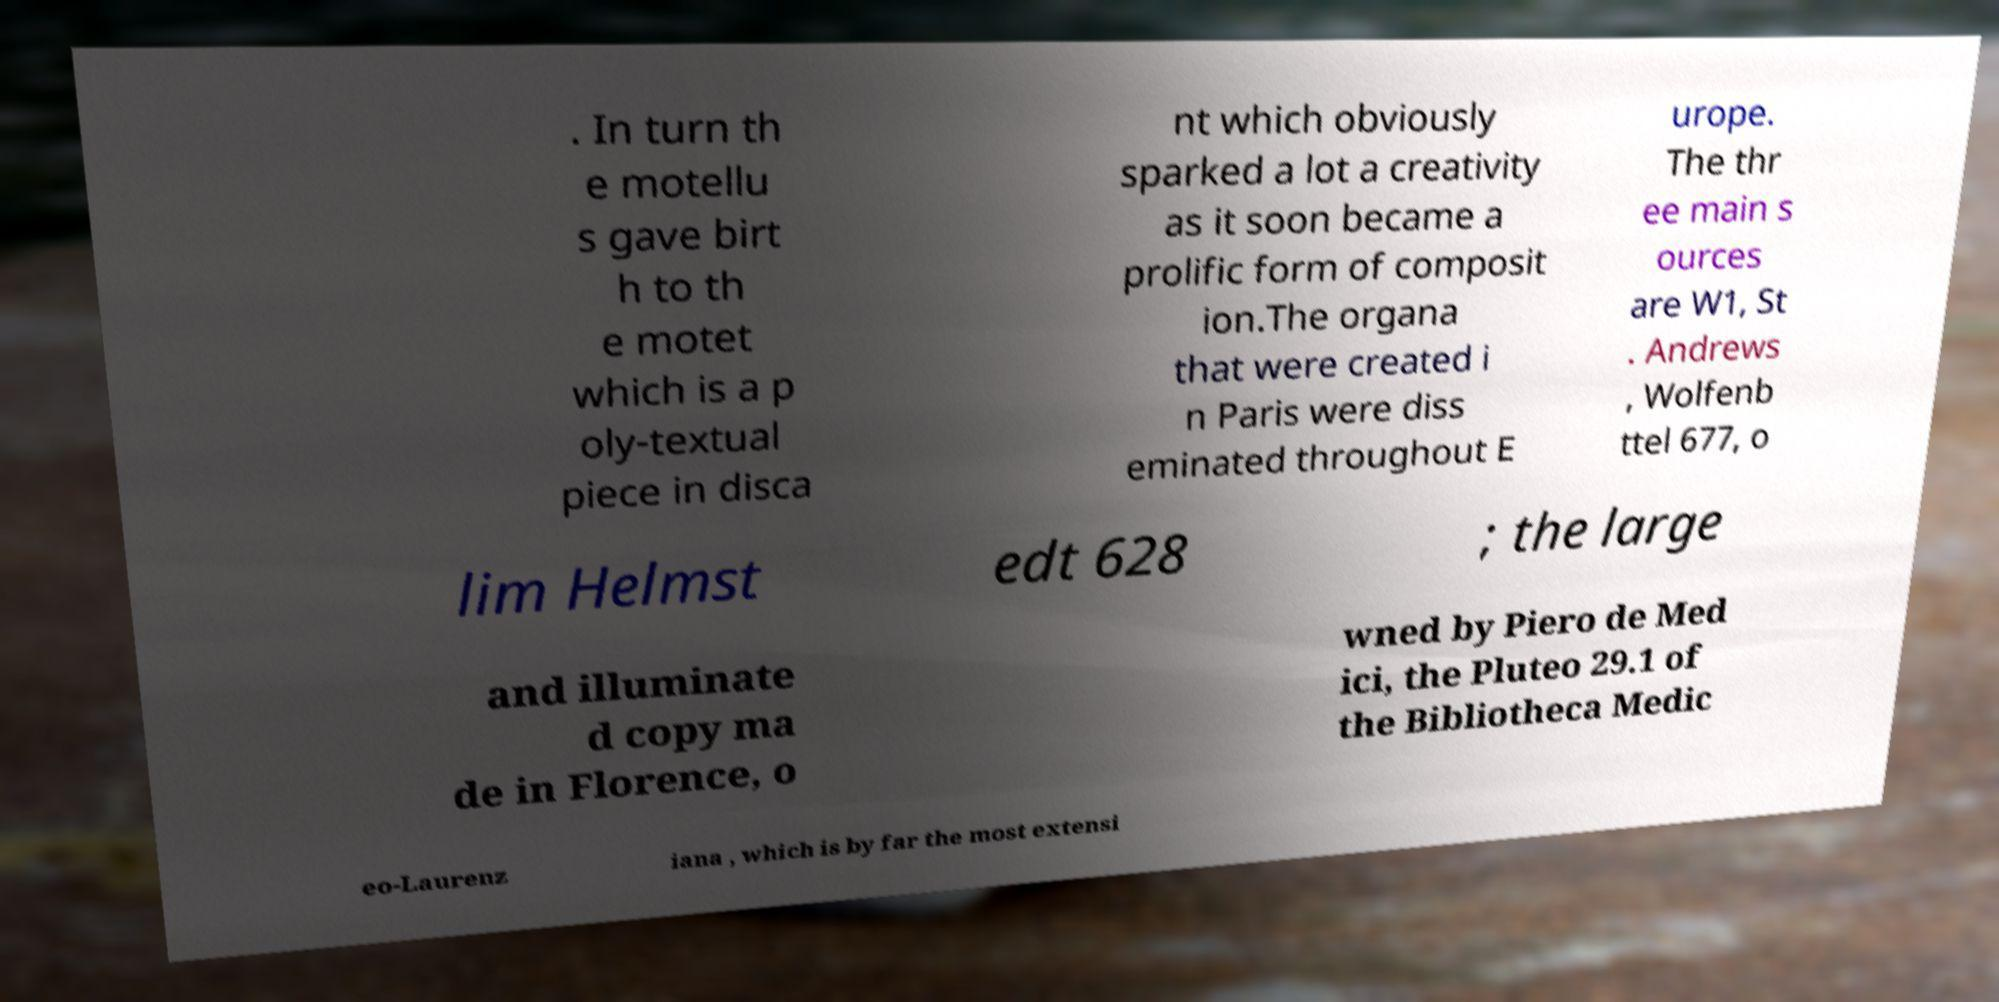I need the written content from this picture converted into text. Can you do that? . In turn th e motellu s gave birt h to th e motet which is a p oly-textual piece in disca nt which obviously sparked a lot a creativity as it soon became a prolific form of composit ion.The organa that were created i n Paris were diss eminated throughout E urope. The thr ee main s ources are W1, St . Andrews , Wolfenb ttel 677, o lim Helmst edt 628 ; the large and illuminate d copy ma de in Florence, o wned by Piero de Med ici, the Pluteo 29.1 of the Bibliotheca Medic eo-Laurenz iana , which is by far the most extensi 